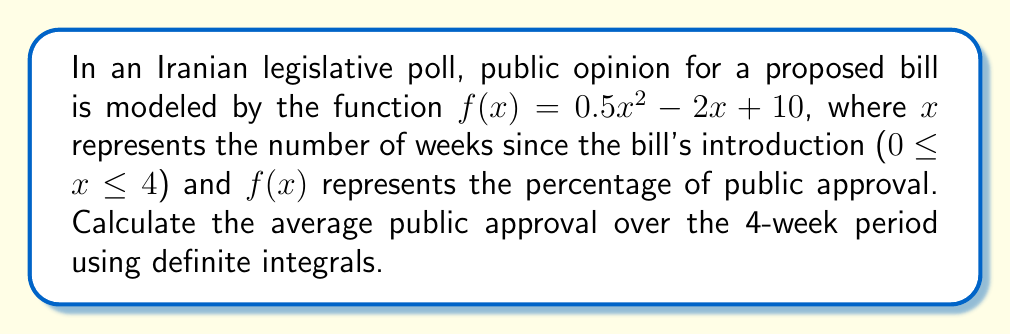Can you answer this question? To find the average public approval over the 4-week period, we need to:

1. Calculate the area under the curve from $x = 0$ to $x = 4$.
2. Divide the result by the interval length (4 weeks) to get the average.

Step 1: Calculate the definite integral

$$\int_0^4 (0.5x^2 - 2x + 10) dx$$

Step 2: Integrate the function
$$\left[\frac{1}{6}x^3 - x^2 + 10x\right]_0^4$$

Step 3: Evaluate the integral
$$\left(\frac{1}{6}(4^3) - 4^2 + 10(4)\right) - \left(\frac{1}{6}(0^3) - 0^2 + 10(0)\right)$$
$$= (10.67 - 16 + 40) - (0 - 0 + 0) = 34.67$$

Step 4: Divide by the interval length to get the average
$$\frac{34.67}{4} = 8.67$$

Therefore, the average public approval over the 4-week period is 8.67%.
Answer: 8.67% 